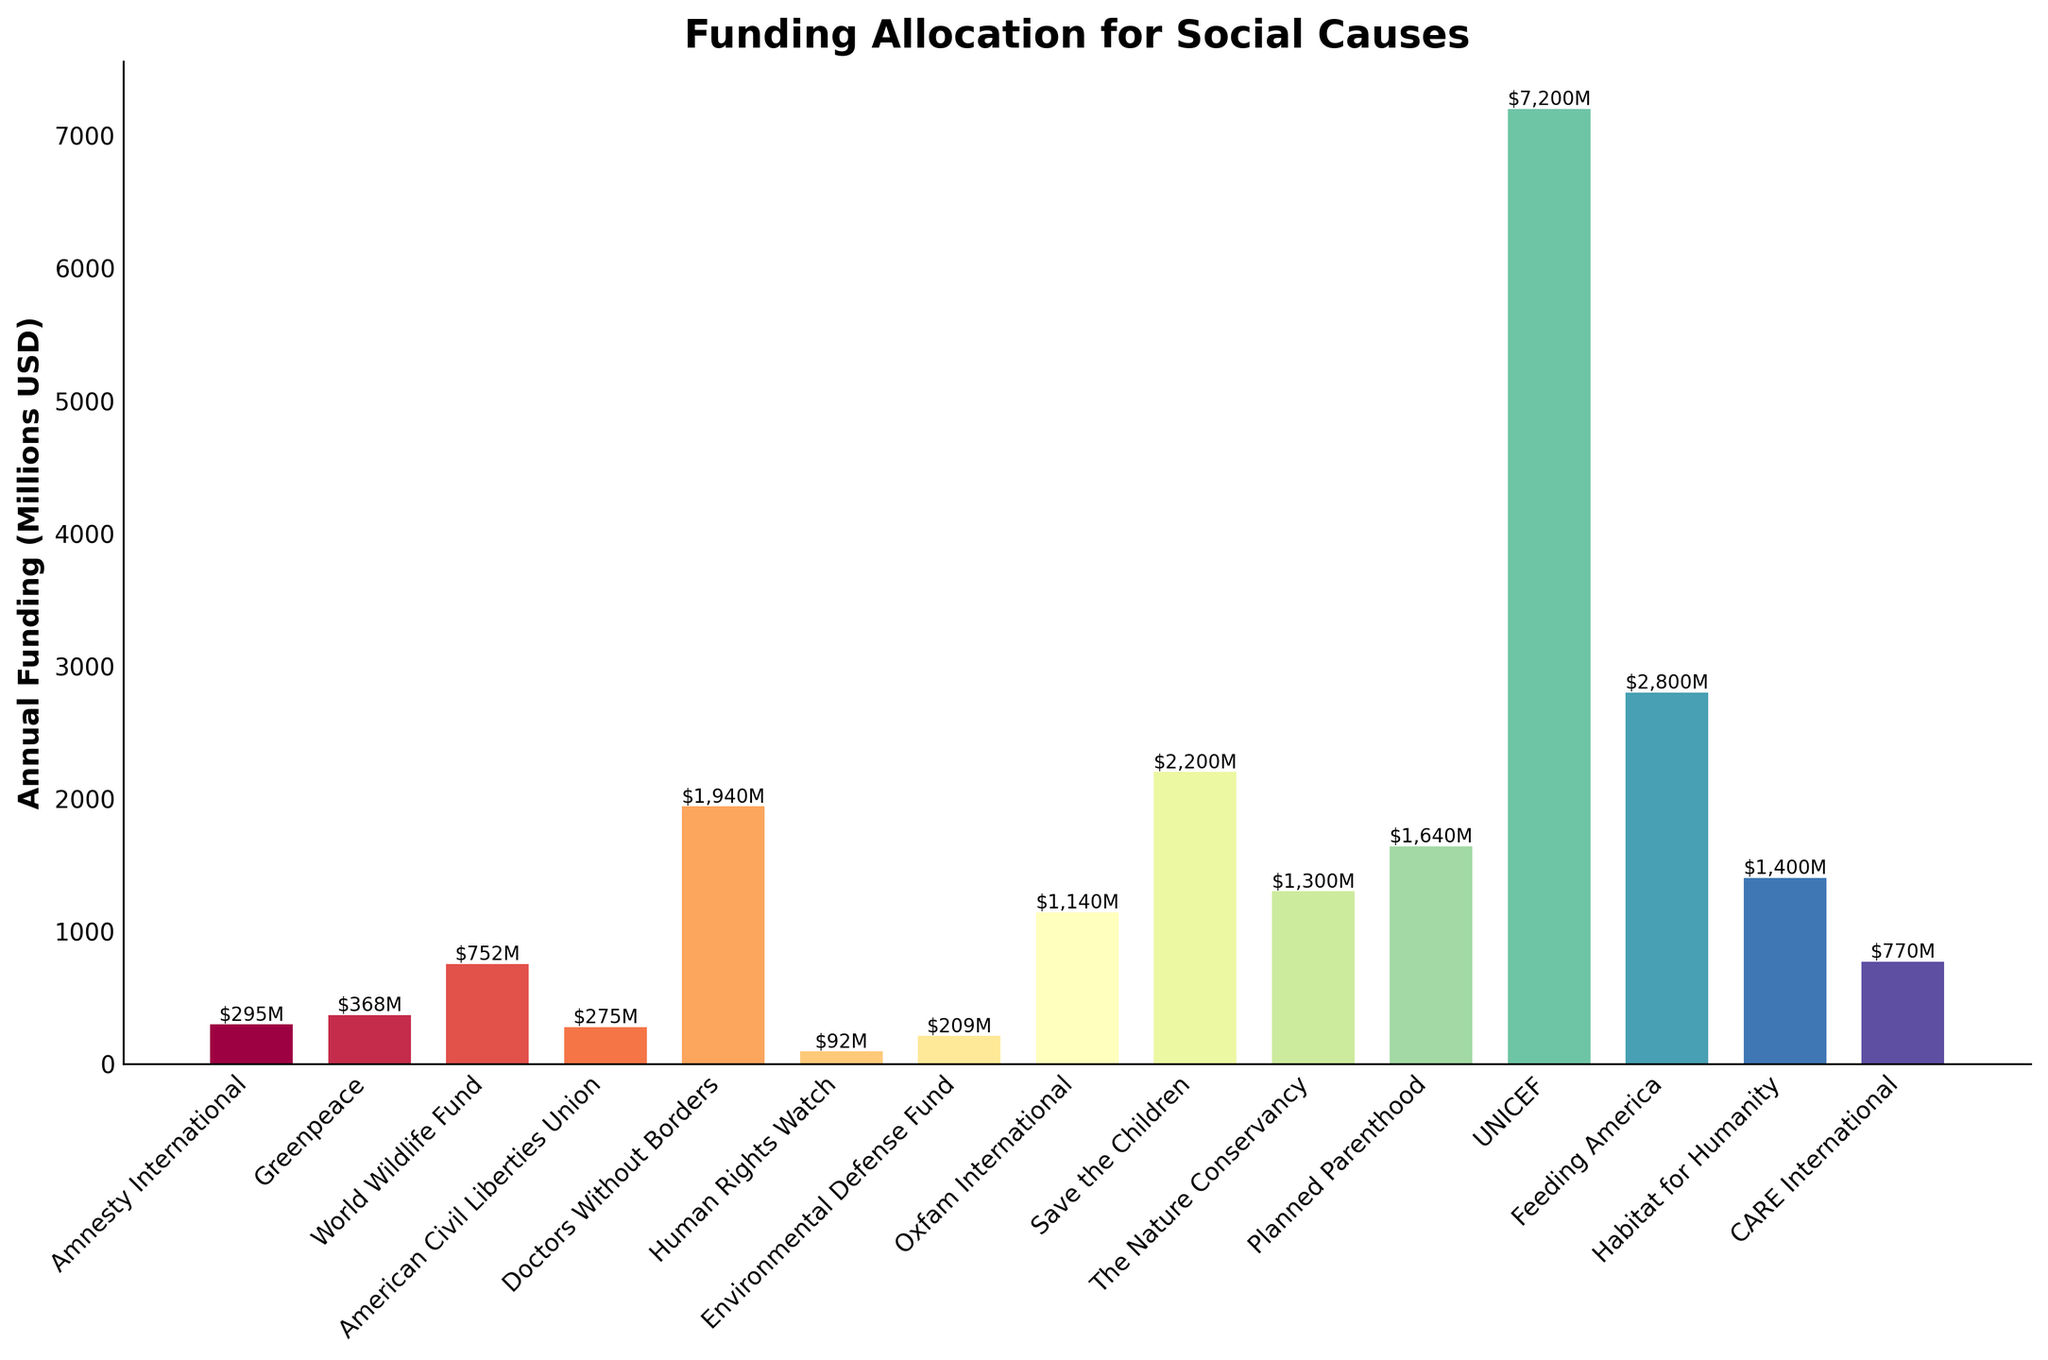Which organization has the highest annual funding? The bar chart visually shows the different heights of bars for various organizations. The highest bar corresponds to UNICEF.
Answer: UNICEF What is the difference in annual funding between Save the Children and Planned Parenthood? From the chart, Save the Children has an annual funding of $2200 million, and Planned Parenthood has $1640 million. The difference is $2200M - $1640M = $560 million.
Answer: $560 million Which organization has lower annual funding: Environmental Defense Fund or Oxfam International? By examining the chart, Oxfam International has a much higher bar than the Environmental Defense Fund. Oxfam International has $1140 million, while the Environmental Defense Fund has $209 million.
Answer: Environmental Defense Fund What is the total annual funding for the three organizations with the least funding? The organizations with the shortest bars are Human Rights Watch, Amnesty International, and American Civil Liberties Union, with $92M, $295M, and $275M respectively. The total is $92M + $295M + $275M = $662 million.
Answer: $662 million How does the annual funding of The Nature Conservancy compare to that of Habitat for Humanity? The Nature Conservancy has a bar representing $1300 million, while Habitat for Humanity has a bar representing $1400 million. Habitat for Humanity has higher funding.
Answer: Habitat for Humanity Which organizations fall within the funding range of $500 million to $1500 million? The bars for World Wildlife Fund, Oxfam International, Habitat for Humanity, and The Nature Conservancy all fall within this range. Specifically, they have $752M, $1140M, $1400M, and $1300M respectively.
Answer: World Wildlife Fund, Oxfam International, Habitat for Humanity, The Nature Conservancy What is the average annual funding of Amnesty International, Greenpeace, and Human Rights Watch? The annual funding for these organizations is $295M (Amnesty International), $368M (Greenpeace), and $92M (Human Rights Watch). Adding them gives $295M + $368M + $92M = $755M, and the average is $755M / 3 = $251.67 million.
Answer: $251.67 million How many organizations receive more than $1 billion annually? Organizations like Doctors Without Borders, Oxfam International, Save the Children, Planned Parenthood, UNICEF, and Feeding America have bars surpassing $1 billion. Counting these gives us six organizations.
Answer: Six organizations If the sum of funding for all organizations is $14,000 million, what percentage of total funding is allocated to Feeding America? Feeding America's funding is $2800M. The percentage is calculated as ($2800M / $14,000M) * 100% = 20%.
Answer: 20% 